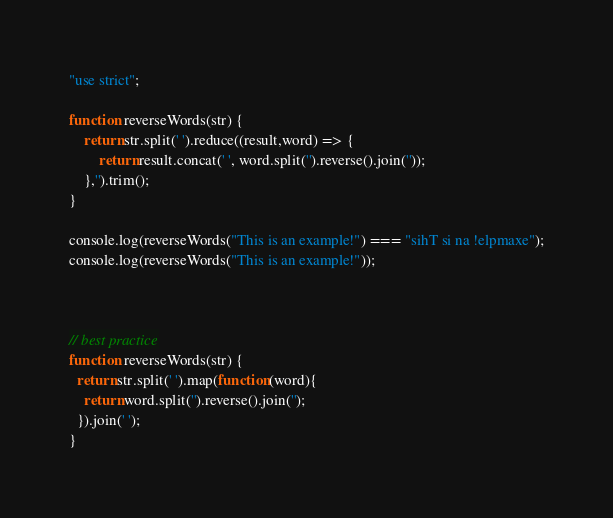<code> <loc_0><loc_0><loc_500><loc_500><_JavaScript_>"use strict";

function reverseWords(str) {
	return str.split(' ').reduce((result,word) => {
		return result.concat(' ', word.split('').reverse().join(''));
	},'').trim();
}

console.log(reverseWords("This is an example!") === "sihT si na !elpmaxe");
console.log(reverseWords("This is an example!"));



// best practice
function reverseWords(str) {
  return str.split(' ').map(function(word){
    return word.split('').reverse().join('');
  }).join(' ');
}</code> 